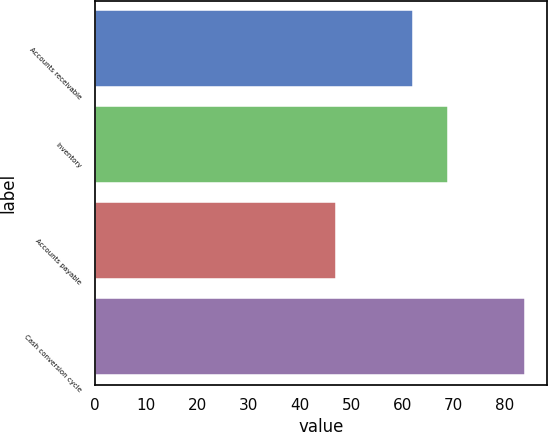<chart> <loc_0><loc_0><loc_500><loc_500><bar_chart><fcel>Accounts receivable<fcel>Inventory<fcel>Accounts payable<fcel>Cash conversion cycle<nl><fcel>62<fcel>69<fcel>47<fcel>84<nl></chart> 